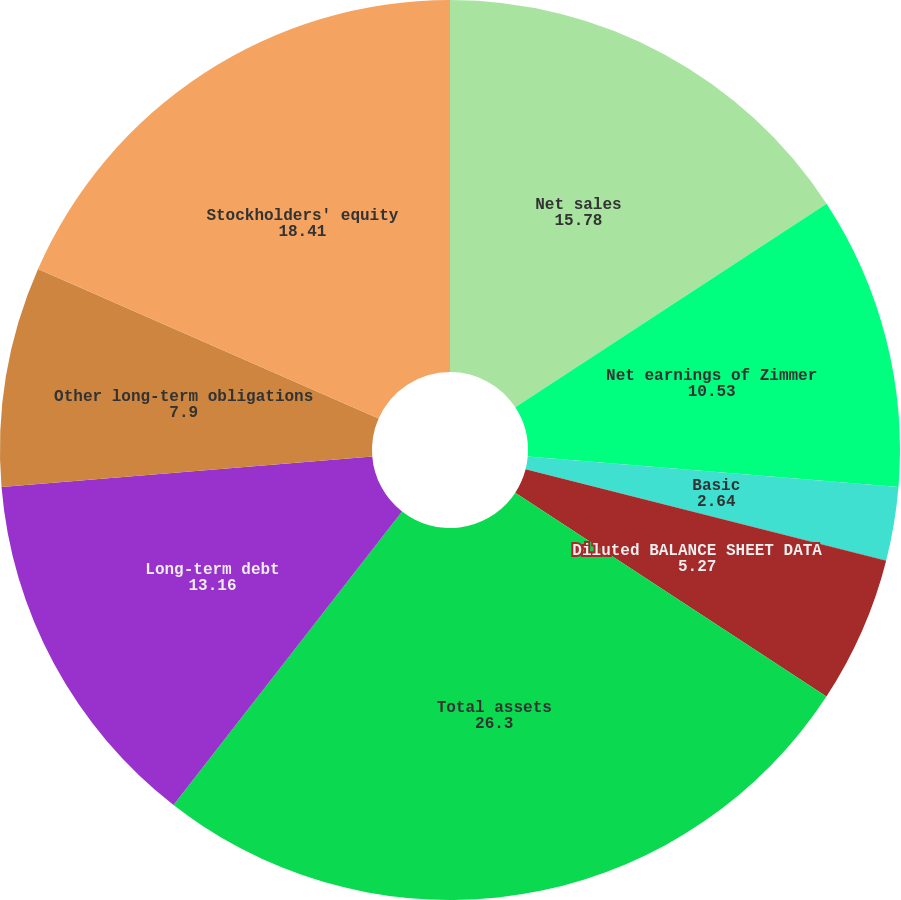<chart> <loc_0><loc_0><loc_500><loc_500><pie_chart><fcel>Net sales<fcel>Net earnings of Zimmer<fcel>Basic<fcel>Diluted<fcel>Diluted BALANCE SHEET DATA<fcel>Total assets<fcel>Long-term debt<fcel>Other long-term obligations<fcel>Stockholders' equity<nl><fcel>15.78%<fcel>10.53%<fcel>2.64%<fcel>0.01%<fcel>5.27%<fcel>26.3%<fcel>13.16%<fcel>7.9%<fcel>18.41%<nl></chart> 